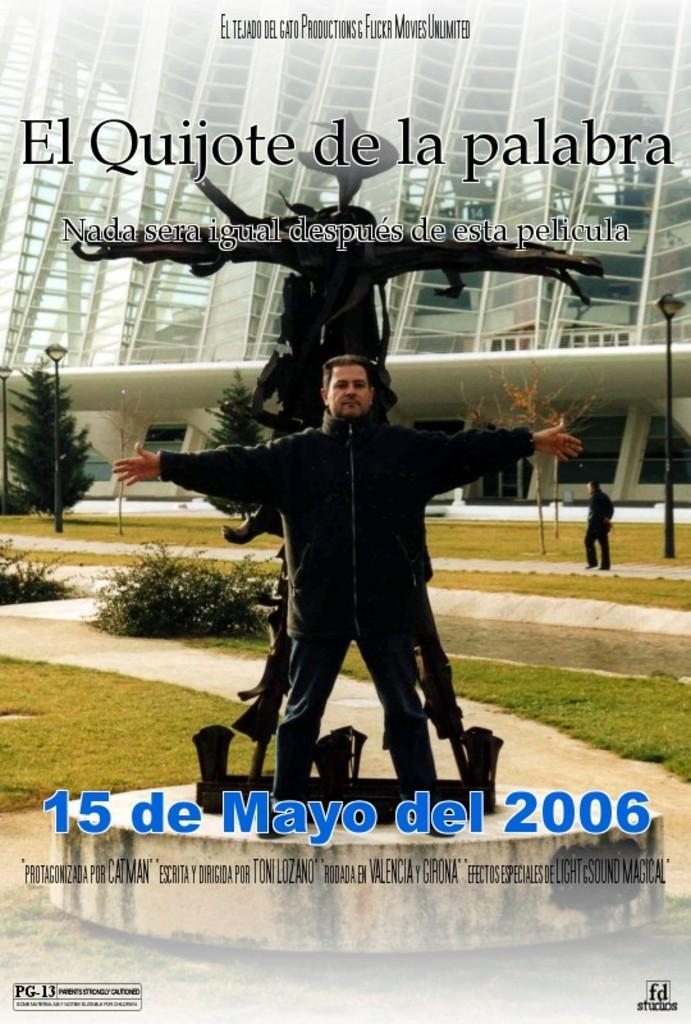<image>
Describe the image concisely. A poster includes a man imitating a statue behind him and has the date of an event noted. 